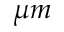Convert formula to latex. <formula><loc_0><loc_0><loc_500><loc_500>\mu m</formula> 